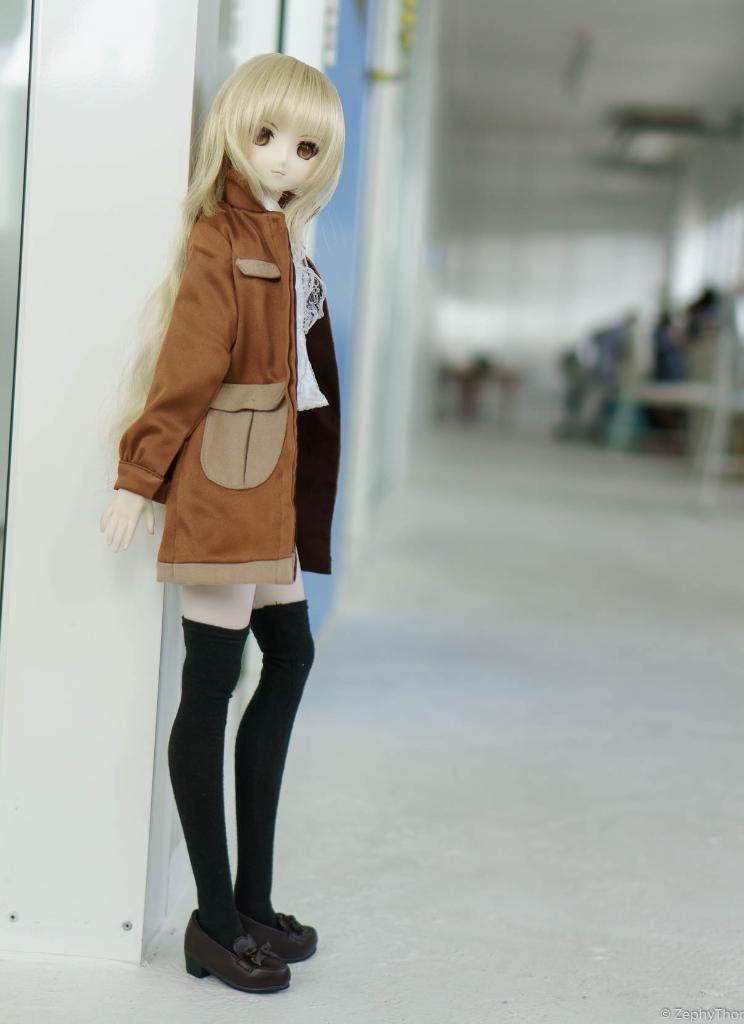Could you give a brief overview of what you see in this image? As we can see in the image there is a wall and a toy in the front. The background is blurred. 